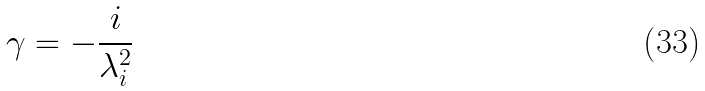Convert formula to latex. <formula><loc_0><loc_0><loc_500><loc_500>\gamma = - \frac { i } { \lambda _ { i } ^ { 2 } }</formula> 